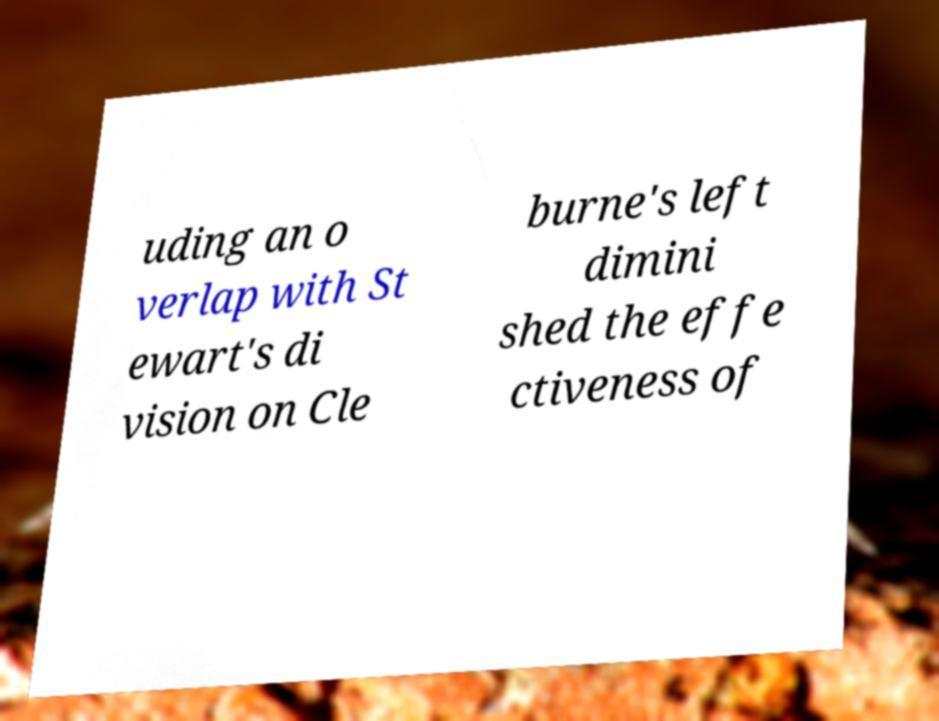I need the written content from this picture converted into text. Can you do that? uding an o verlap with St ewart's di vision on Cle burne's left dimini shed the effe ctiveness of 